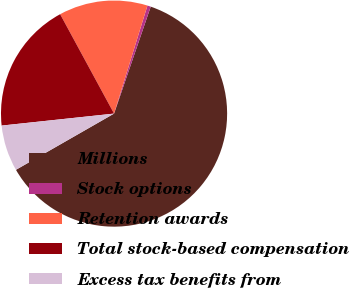Convert chart. <chart><loc_0><loc_0><loc_500><loc_500><pie_chart><fcel>Millions<fcel>Stock options<fcel>Retention awards<fcel>Total stock-based compensation<fcel>Excess tax benefits from<nl><fcel>61.46%<fcel>0.49%<fcel>12.68%<fcel>18.78%<fcel>6.59%<nl></chart> 